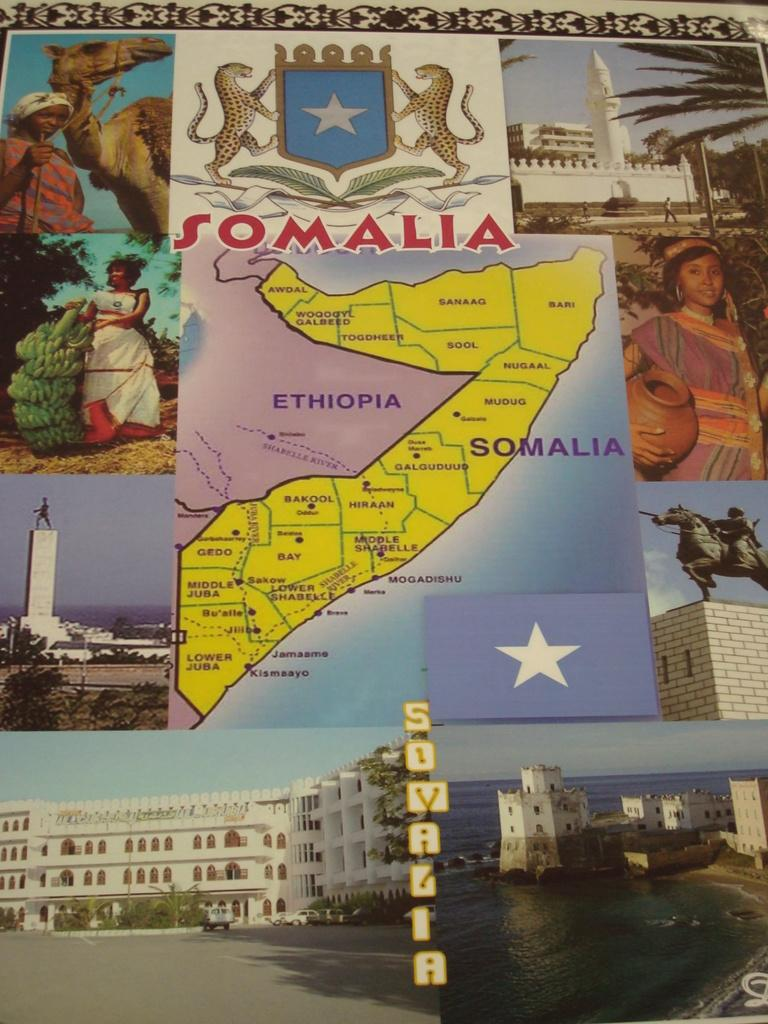Provide a one-sentence caption for the provided image. Somalia and Ethiopia are shown on a map of the region. 